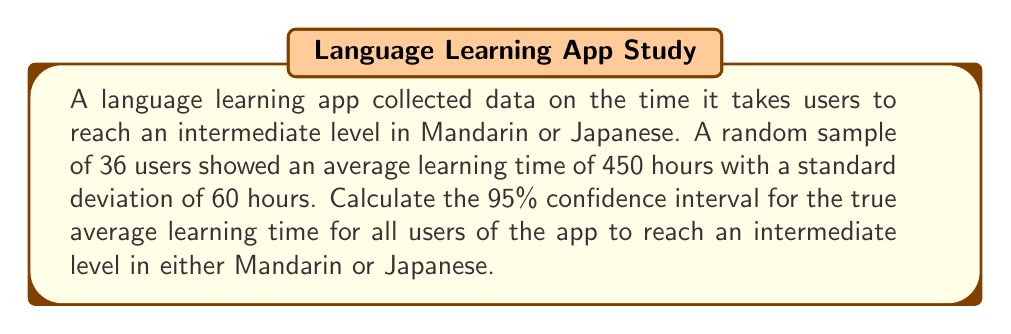Can you answer this question? To calculate the confidence interval, we'll follow these steps:

1. Identify the given information:
   - Sample size: $n = 36$
   - Sample mean: $\bar{x} = 450$ hours
   - Sample standard deviation: $s = 60$ hours
   - Confidence level: 95% (α = 0.05)

2. Find the critical value ($t$-score) for a 95% confidence interval:
   - Degrees of freedom: $df = n - 1 = 36 - 1 = 35$
   - Using a t-table or calculator, we find $t_{0.025, 35} \approx 2.030$

3. Calculate the margin of error:
   $\text{Margin of Error} = t_{0.025, 35} \cdot \frac{s}{\sqrt{n}}$
   $\text{Margin of Error} = 2.030 \cdot \frac{60}{\sqrt{36}} \approx 20.30$

4. Compute the confidence interval:
   $\text{CI} = \bar{x} \pm \text{Margin of Error}$
   $\text{CI} = 450 \pm 20.30$
   
   Lower bound: $450 - 20.30 = 429.70$
   Upper bound: $450 + 20.30 = 470.30$

Therefore, the 95% confidence interval for the true average learning time is approximately (429.70, 470.30) hours.
Answer: (429.70, 470.30) hours 